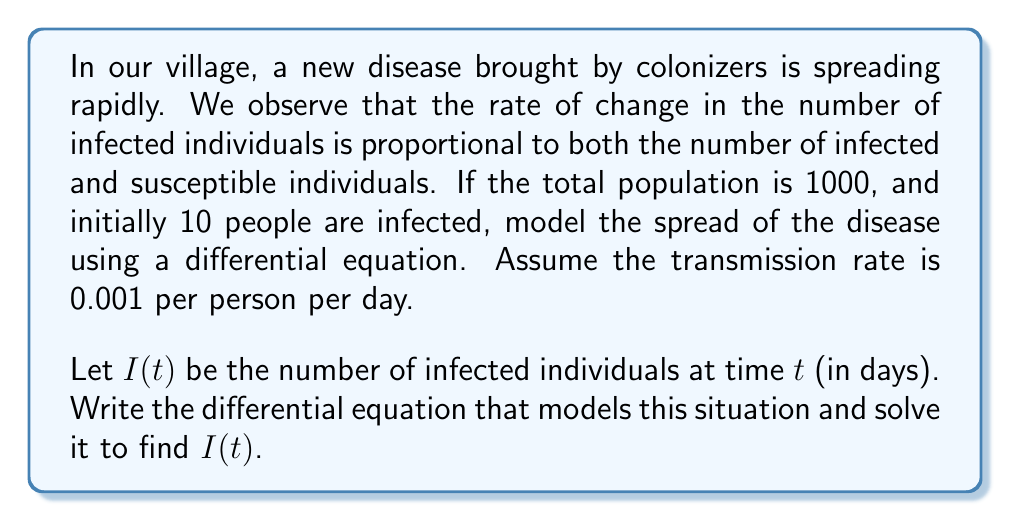What is the answer to this math problem? Let's approach this step-by-step:

1) The total population is $N = 1000$, and the number of infected individuals is $I(t)$. Therefore, the number of susceptible individuals is $S(t) = N - I(t) = 1000 - I(t)$.

2) The rate of change in infected individuals is proportional to both infected and susceptible individuals:

   $$\frac{dI}{dt} = \beta S(t)I(t)$$

   where $\beta$ is the transmission rate (0.001 per person per day).

3) Substituting $S(t) = 1000 - I(t)$:

   $$\frac{dI}{dt} = 0.001(1000 - I)I = I - 0.001I^2$$

4) This is a logistic differential equation. The general solution is:

   $$I(t) = \frac{K}{1 + Ce^{-rt}}$$

   where $K$ is the carrying capacity (1000 in this case), $r$ is the growth rate (1 in this case), and $C$ is a constant to be determined.

5) Initially, $I(0) = 10$. Substituting this into the general solution:

   $$10 = \frac{1000}{1 + C}$$

   Solving for $C$:

   $$C = 99$$

6) Therefore, the solution is:

   $$I(t) = \frac{1000}{1 + 99e^{-t}}$$

This equation models the number of infected individuals in the village over time.
Answer: $I(t) = \frac{1000}{1 + 99e^{-t}}$ 